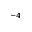Convert formula to latex. <formula><loc_0><loc_0><loc_500><loc_500>^ { - 4 }</formula> 